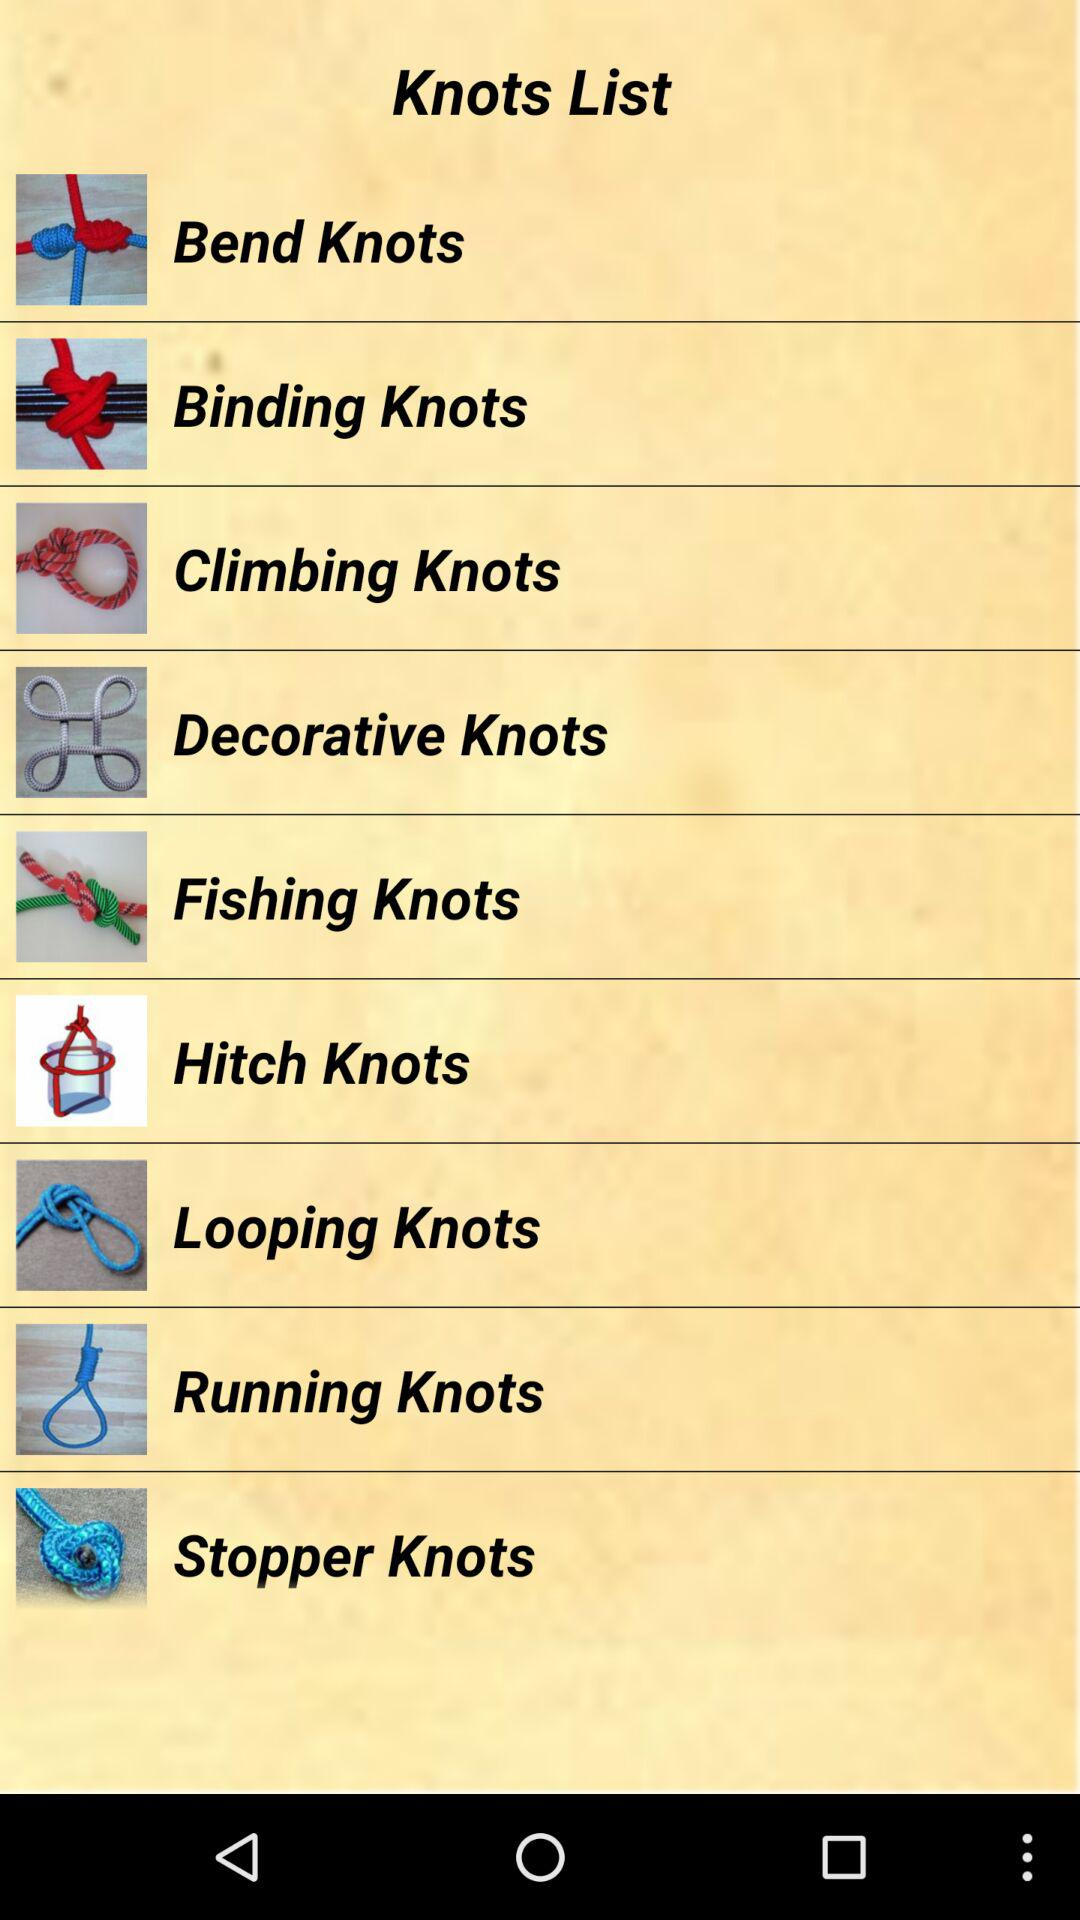What are the available knots? The available knots are "Bend Knots", "Binding Knots", "Climbing Knots", "Decorative Knots", "Fishing Knots", "Hitch Knots", "Looping Knots", "Running Knots" and "Stopper Knots". 